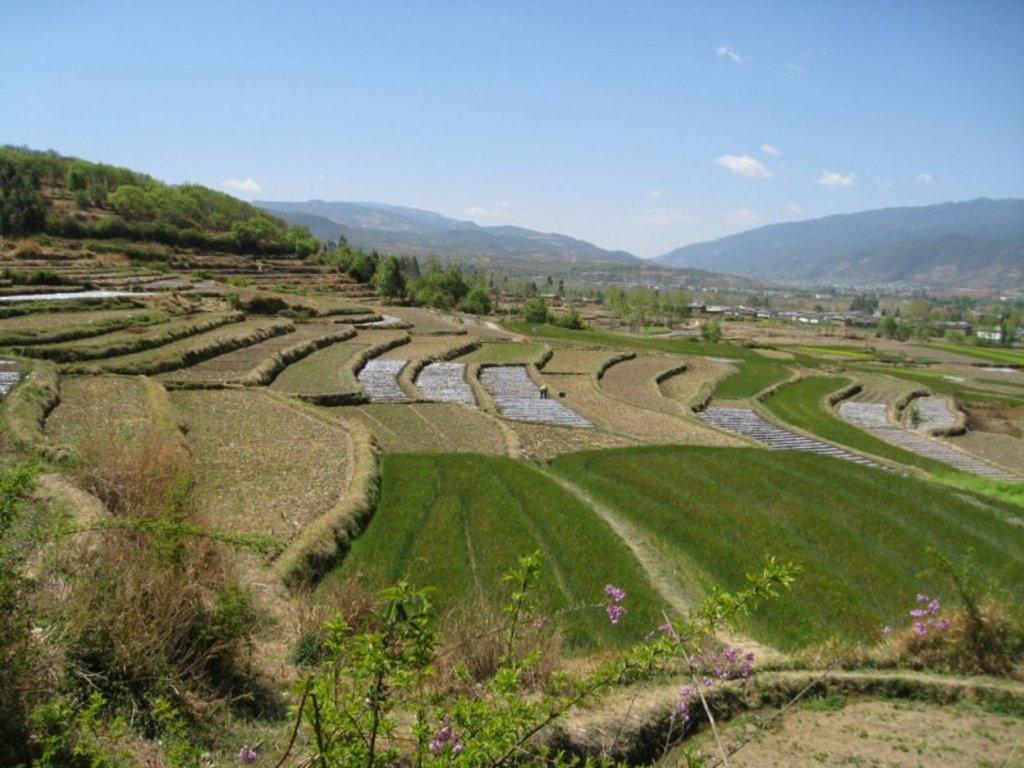How would you summarize this image in a sentence or two? In this image I can see small plants,dry grass and flowers. Back Side I can see trees and houses. We can see mountains. The sky is in blue and white color. 